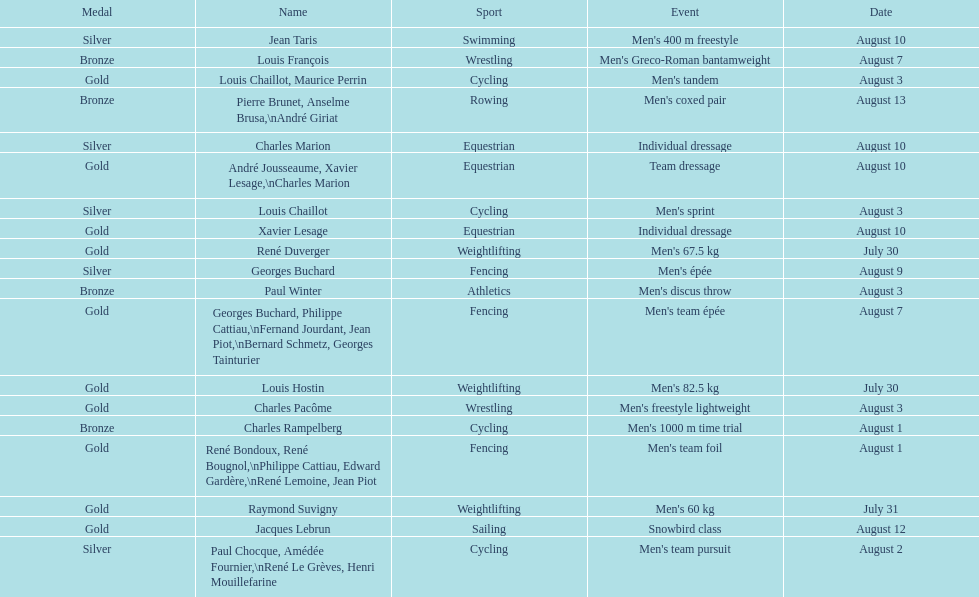Was there more gold medals won than silver? Yes. 